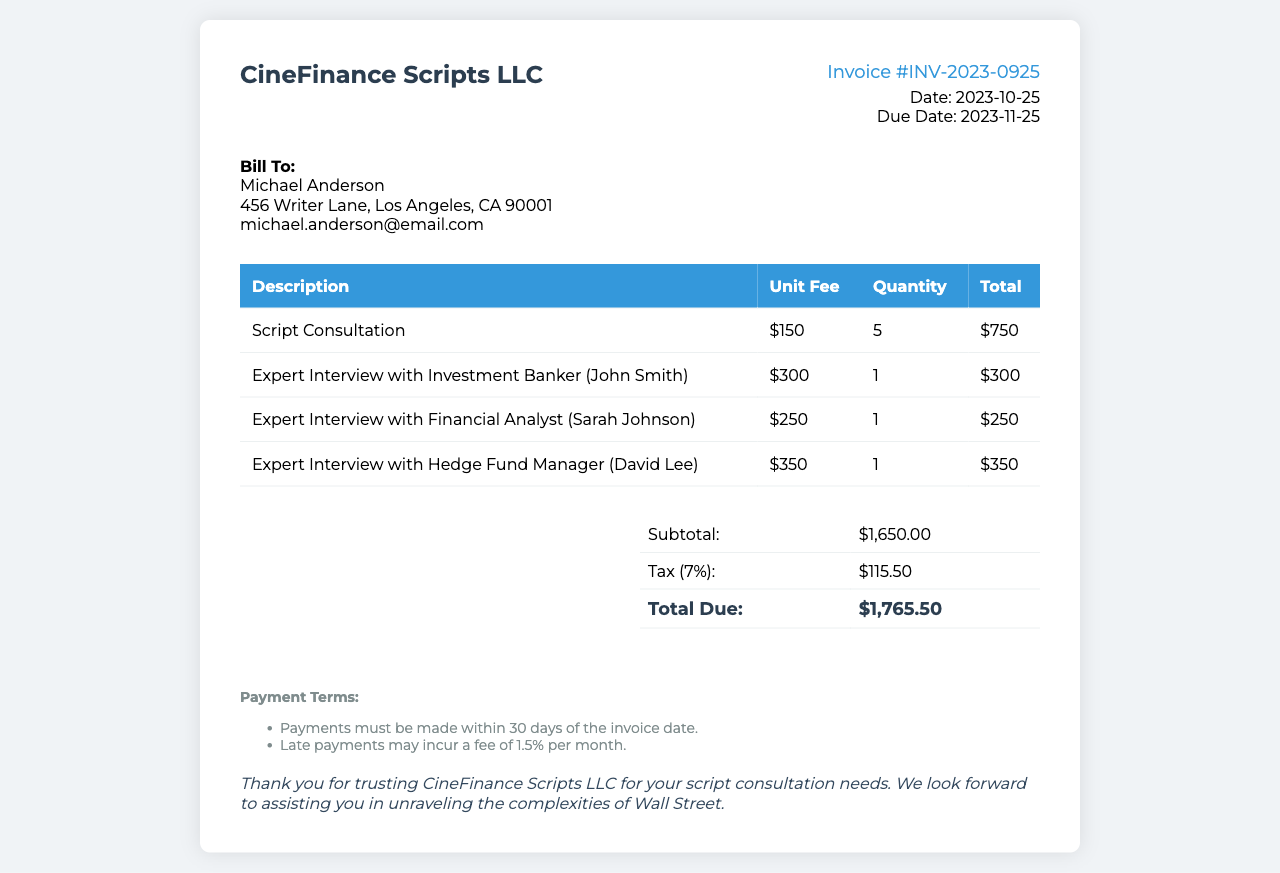What is the invoice number? The invoice number is mentioned in the document as a unique identifier for this invoice.
Answer: INV-2023-0925 What is the total due amount? The total due amount can be found in the summary section of the invoice, representing the total balance owed.
Answer: $1,765.50 Who is the client? The client's name is stated at the top of the invoice under client information.
Answer: Michael Anderson How many script consultation sessions are included? The quantity of script consultation sessions is specified in the invoice details.
Answer: 5 What is the subtotal before tax? The subtotal is listed in the summary and reflects the total amount before tax is applied.
Answer: $1,650.00 What is the tax percentage applied? The tax percentage is explicitly stated in the summary section of the invoice.
Answer: 7% When is the payment due date? The due date for payment is provided in the invoice details section.
Answer: 2023-11-25 What is the unit fee for the Hedge Fund Manager interview? The unit fee for the specific interview is found in the table detailing service charges.
Answer: $350 What is the penalty for late payments? The conditions for late payments are indicated in the payment terms section of the invoice.
Answer: 1.5% per month 